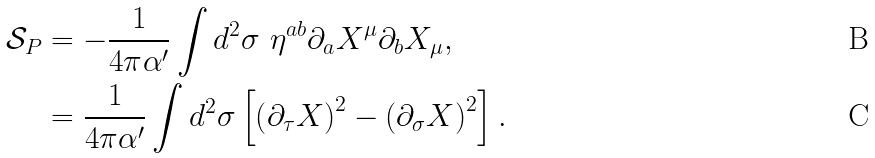<formula> <loc_0><loc_0><loc_500><loc_500>\mathcal { S } _ { P } & = - \frac { 1 } { 4 \pi \alpha ^ { \prime } } \int d ^ { 2 } \sigma \ \eta ^ { a b } \partial _ { a } X ^ { \mu } \partial _ { b } X _ { \mu } , \\ & = \frac { 1 } { 4 \pi \alpha ^ { \prime } } \int d ^ { 2 } \sigma \left [ \left ( \partial _ { \tau } X \right ) ^ { 2 } - \left ( \partial _ { \sigma } X \right ) ^ { 2 } \right ] .</formula> 